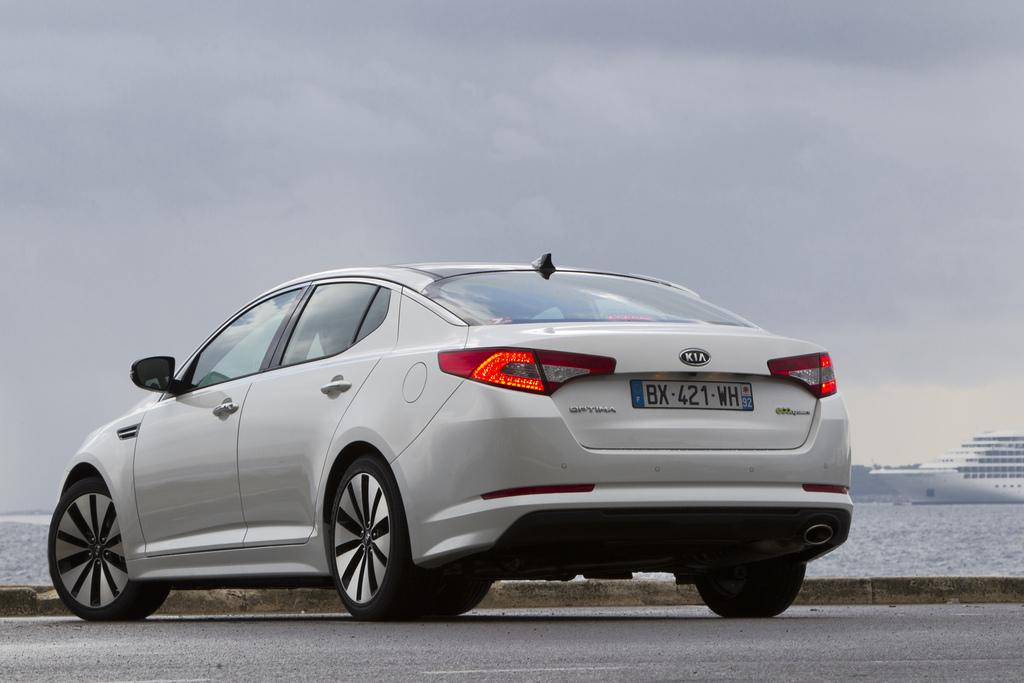What is the main subject of the image? The main subject of the image is a car. Can you describe the car in the image? The car is white and is on the road. What else can be seen in the background of the image? There is a ship visible in the background of the image, and it is on the water. What is visible at the top of the image? The sky is visible at the top of the image. How many women are working in the car industry in the image? There are no women or references to the car industry present in the image. 